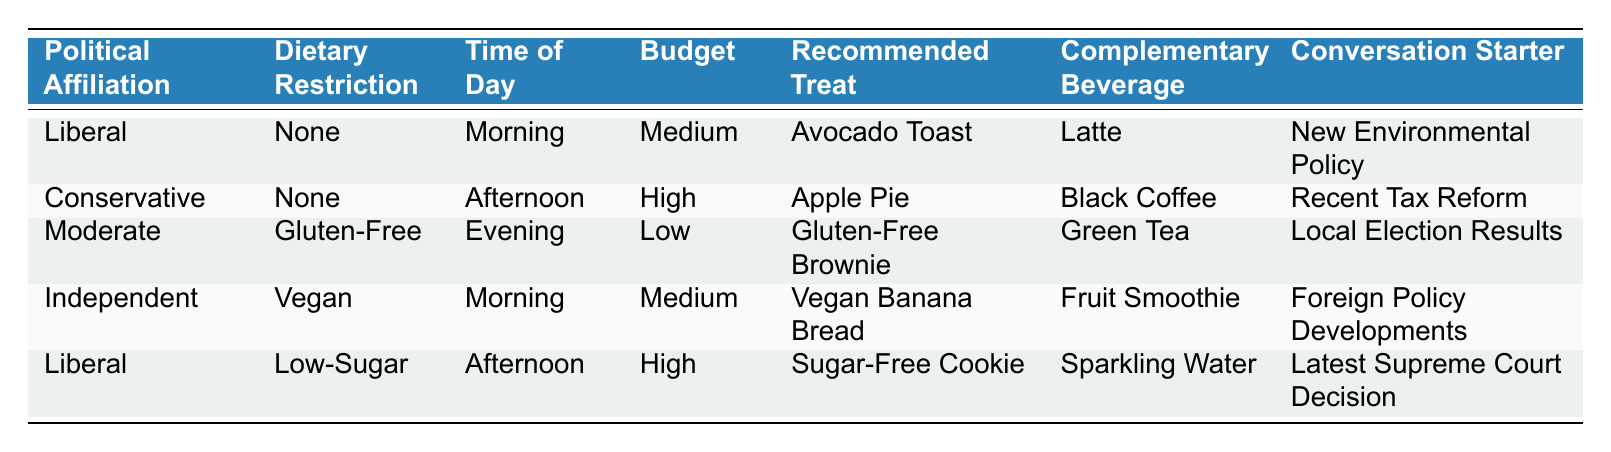What treat is recommended for someone who identifies as Liberal in the morning with no dietary restrictions and a medium budget? Referring to the table, under the "Liberal" political affiliation, "None" dietary restriction, "Morning" time, and "Medium" budget, the recommended treat is "Avocado Toast."
Answer: Avocado Toast Which complementary beverage accompanies the Vegan Banana Bread? Looking at the "Independent" row, which includes "Vegan" dietary restriction, "Morning" time, and "Medium" budget, the complementary beverage listed is "Fruit Smoothie."
Answer: Fruit Smoothie Is the recommended treat for Conservatives in the afternoon always high budget? From the table, we see the row for Conservatives has "Apple Pie," recommended in the afternoon at a "High" budget, and there's no mention of other possible financial options. Thus, it cannot be classified as always since it's only specified for one rule.
Answer: No Count the number of treats recommended for someone with a dietary restriction of Gluten-Free. In the table, there is one row specifically for a "Moderate" individual with "Gluten-Free" dietary restriction, which recommends "Gluten-Free Brownie." Thus, the count is 1.
Answer: 1 What political affiliation and budget are associated with Sugar-Free Cookies? According to the table, "Sugar-Free Cookies" are recommended for someone who identifies as "Liberal" and has a "High" budget during the "Afternoon."
Answer: Liberal and High If someone identifies as Moderate and has a Low budget in the evening, what treat will they have? Checking the row under "Moderate," "Gluten-Free" dietary restriction, "Evening" time, and "Low" budget, the recommended treat is "Gluten-Free Brownie."
Answer: Gluten-Free Brownie What is the average budget of all the political affiliations listed in the table? The budgets listed are High (2 times), Medium (3 times), and Low (2 times), leading to a total of 7 rows: Medium represents 2 (2*1), High represents 2 (2*2), and Low represents 2 (2*0). The total is 10 which gives an average of 10 / 7 ≈ 1.43.
Answer: 1.43 Which conversation starter is associated with the treat called Apple Pie? Referring to the "Conservative" row, which recommends "Apple Pie," paired with "Black Coffee," the conversation starter noted is "Recent Tax Reform."
Answer: Recent Tax Reform 